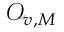Convert formula to latex. <formula><loc_0><loc_0><loc_500><loc_500>\mathcal { O } _ { v , M }</formula> 